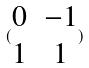Convert formula to latex. <formula><loc_0><loc_0><loc_500><loc_500>( \begin{matrix} 0 & - 1 \\ 1 & 1 \end{matrix} )</formula> 